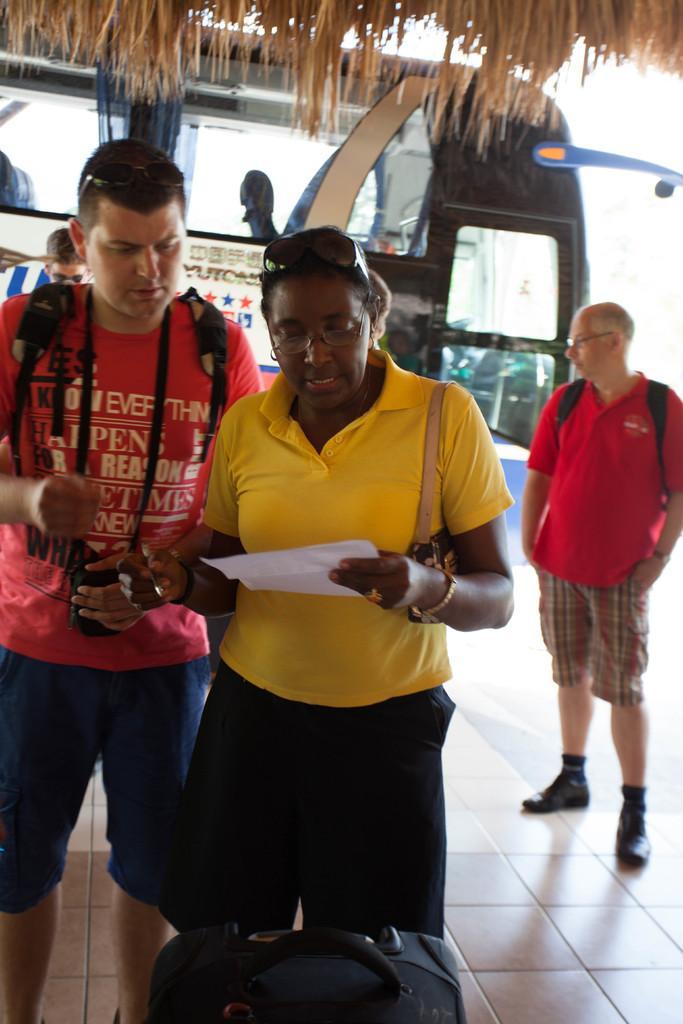Could you give a brief overview of what you see in this image? There is one person standing in the middle is wearing a yellow color t shirt and holding a paper. The person standing on the left side is wearing a backpack and a camera. The person standing on the left side is wearing a red color t shirt and holding a backpack. There is a bus in the background. There is a bag at the bottom of this image. 